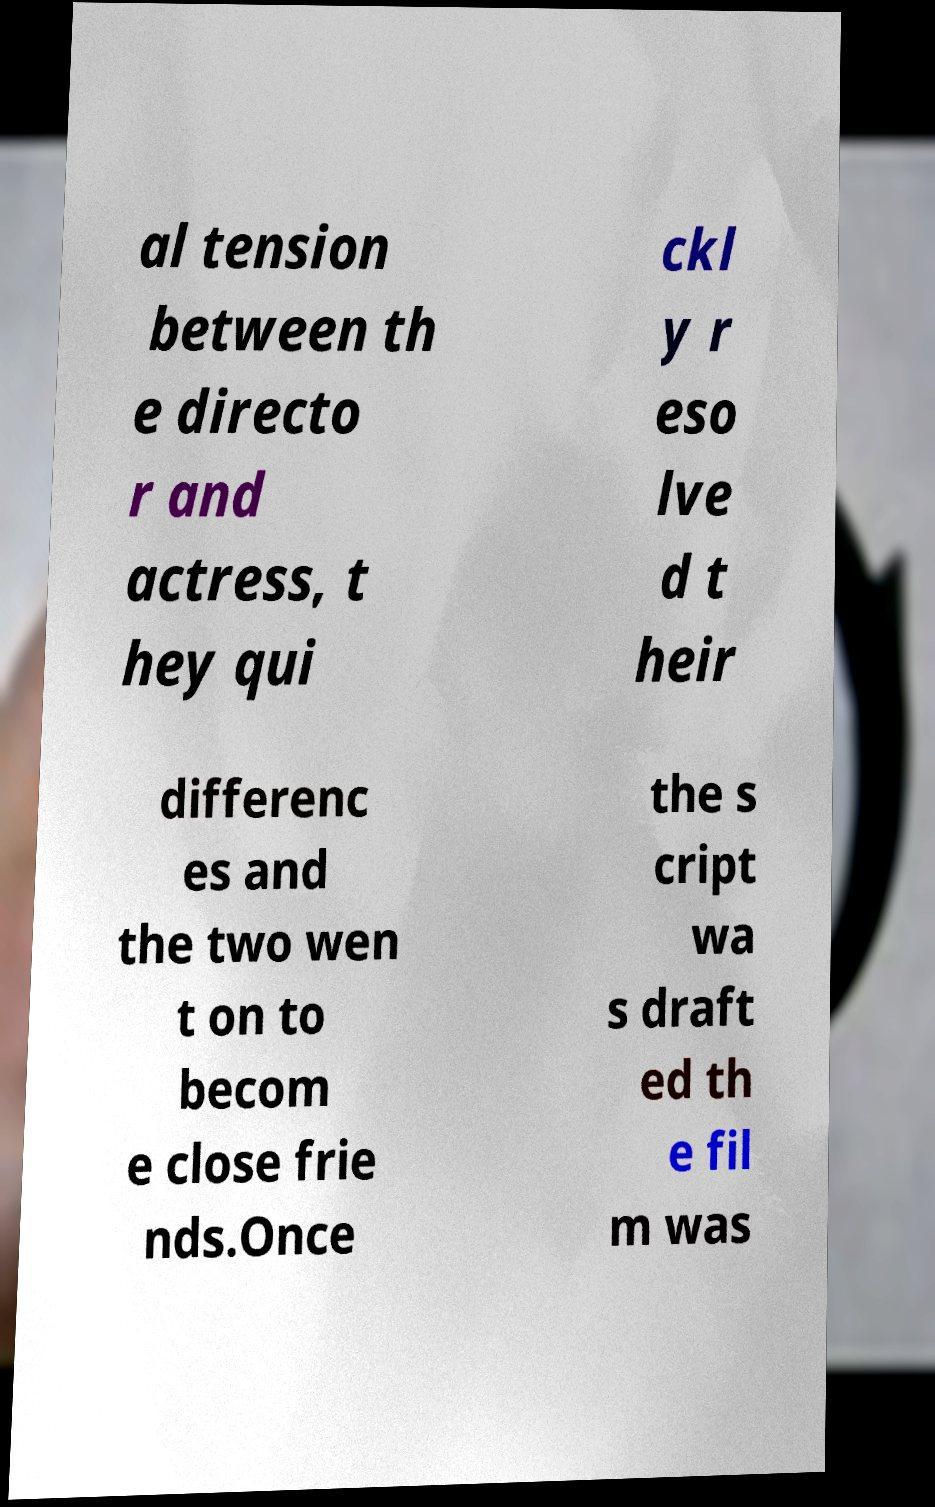There's text embedded in this image that I need extracted. Can you transcribe it verbatim? al tension between th e directo r and actress, t hey qui ckl y r eso lve d t heir differenc es and the two wen t on to becom e close frie nds.Once the s cript wa s draft ed th e fil m was 